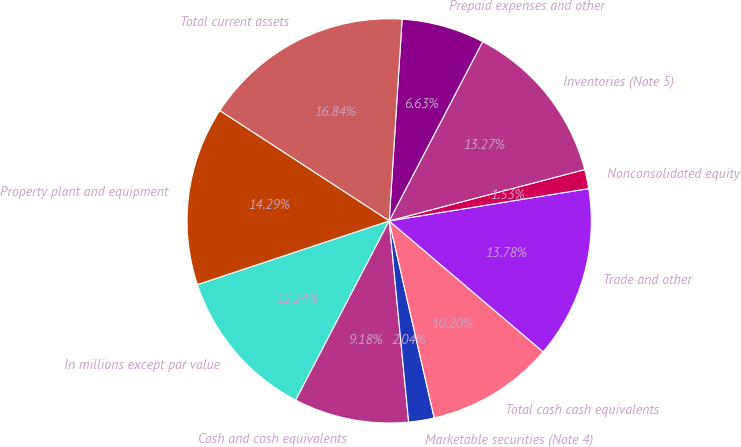Convert chart to OTSL. <chart><loc_0><loc_0><loc_500><loc_500><pie_chart><fcel>In millions except par value<fcel>Cash and cash equivalents<fcel>Marketable securities (Note 4)<fcel>Total cash cash equivalents<fcel>Trade and other<fcel>Nonconsolidated equity<fcel>Inventories (Note 5)<fcel>Prepaid expenses and other<fcel>Total current assets<fcel>Property plant and equipment<nl><fcel>12.24%<fcel>9.18%<fcel>2.04%<fcel>10.2%<fcel>13.77%<fcel>1.53%<fcel>13.26%<fcel>6.63%<fcel>16.83%<fcel>14.28%<nl></chart> 